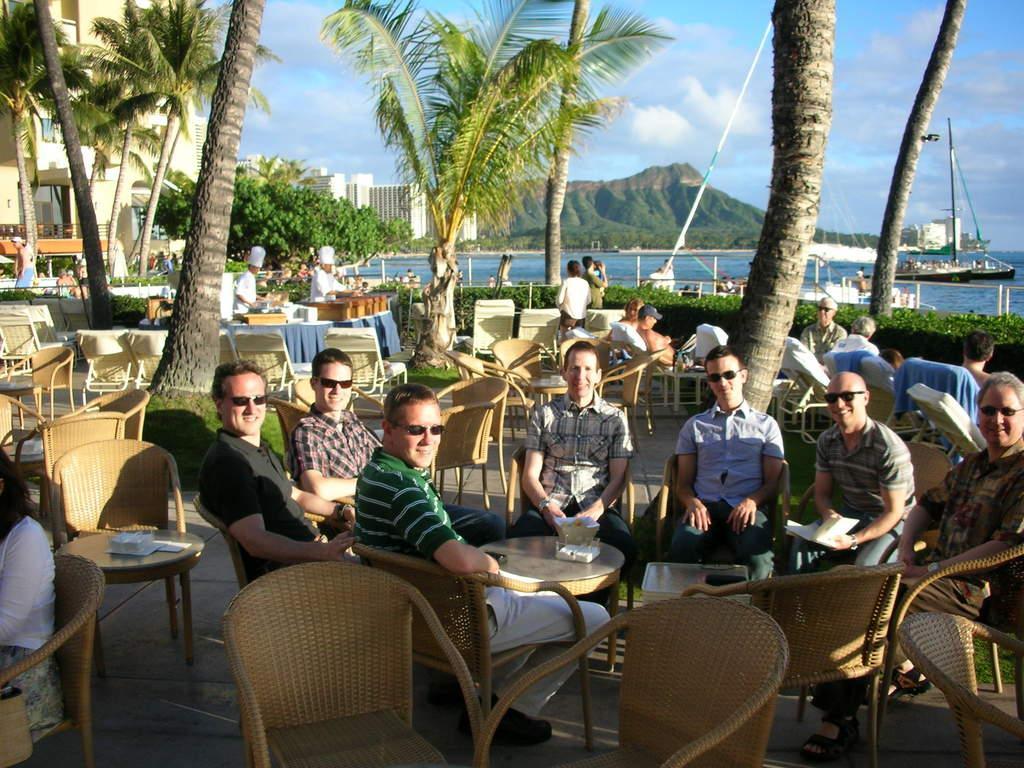Describe this image in one or two sentences. Few persons are sitting on the chair. Few persons standing. We can see building,trees. On the background we can see hill,sky with clouds. water,We can see boat. We can see chairs and table. On the table we can see Things. A far few persons are there. 